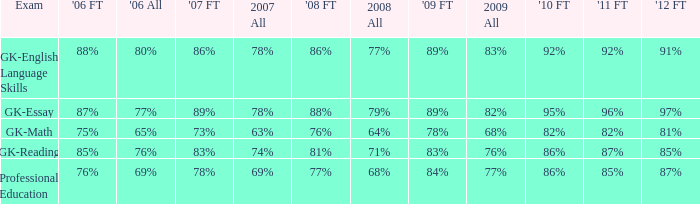What is the percentage for first time 2011 when the first time in 2009 is 68%? 82%. 